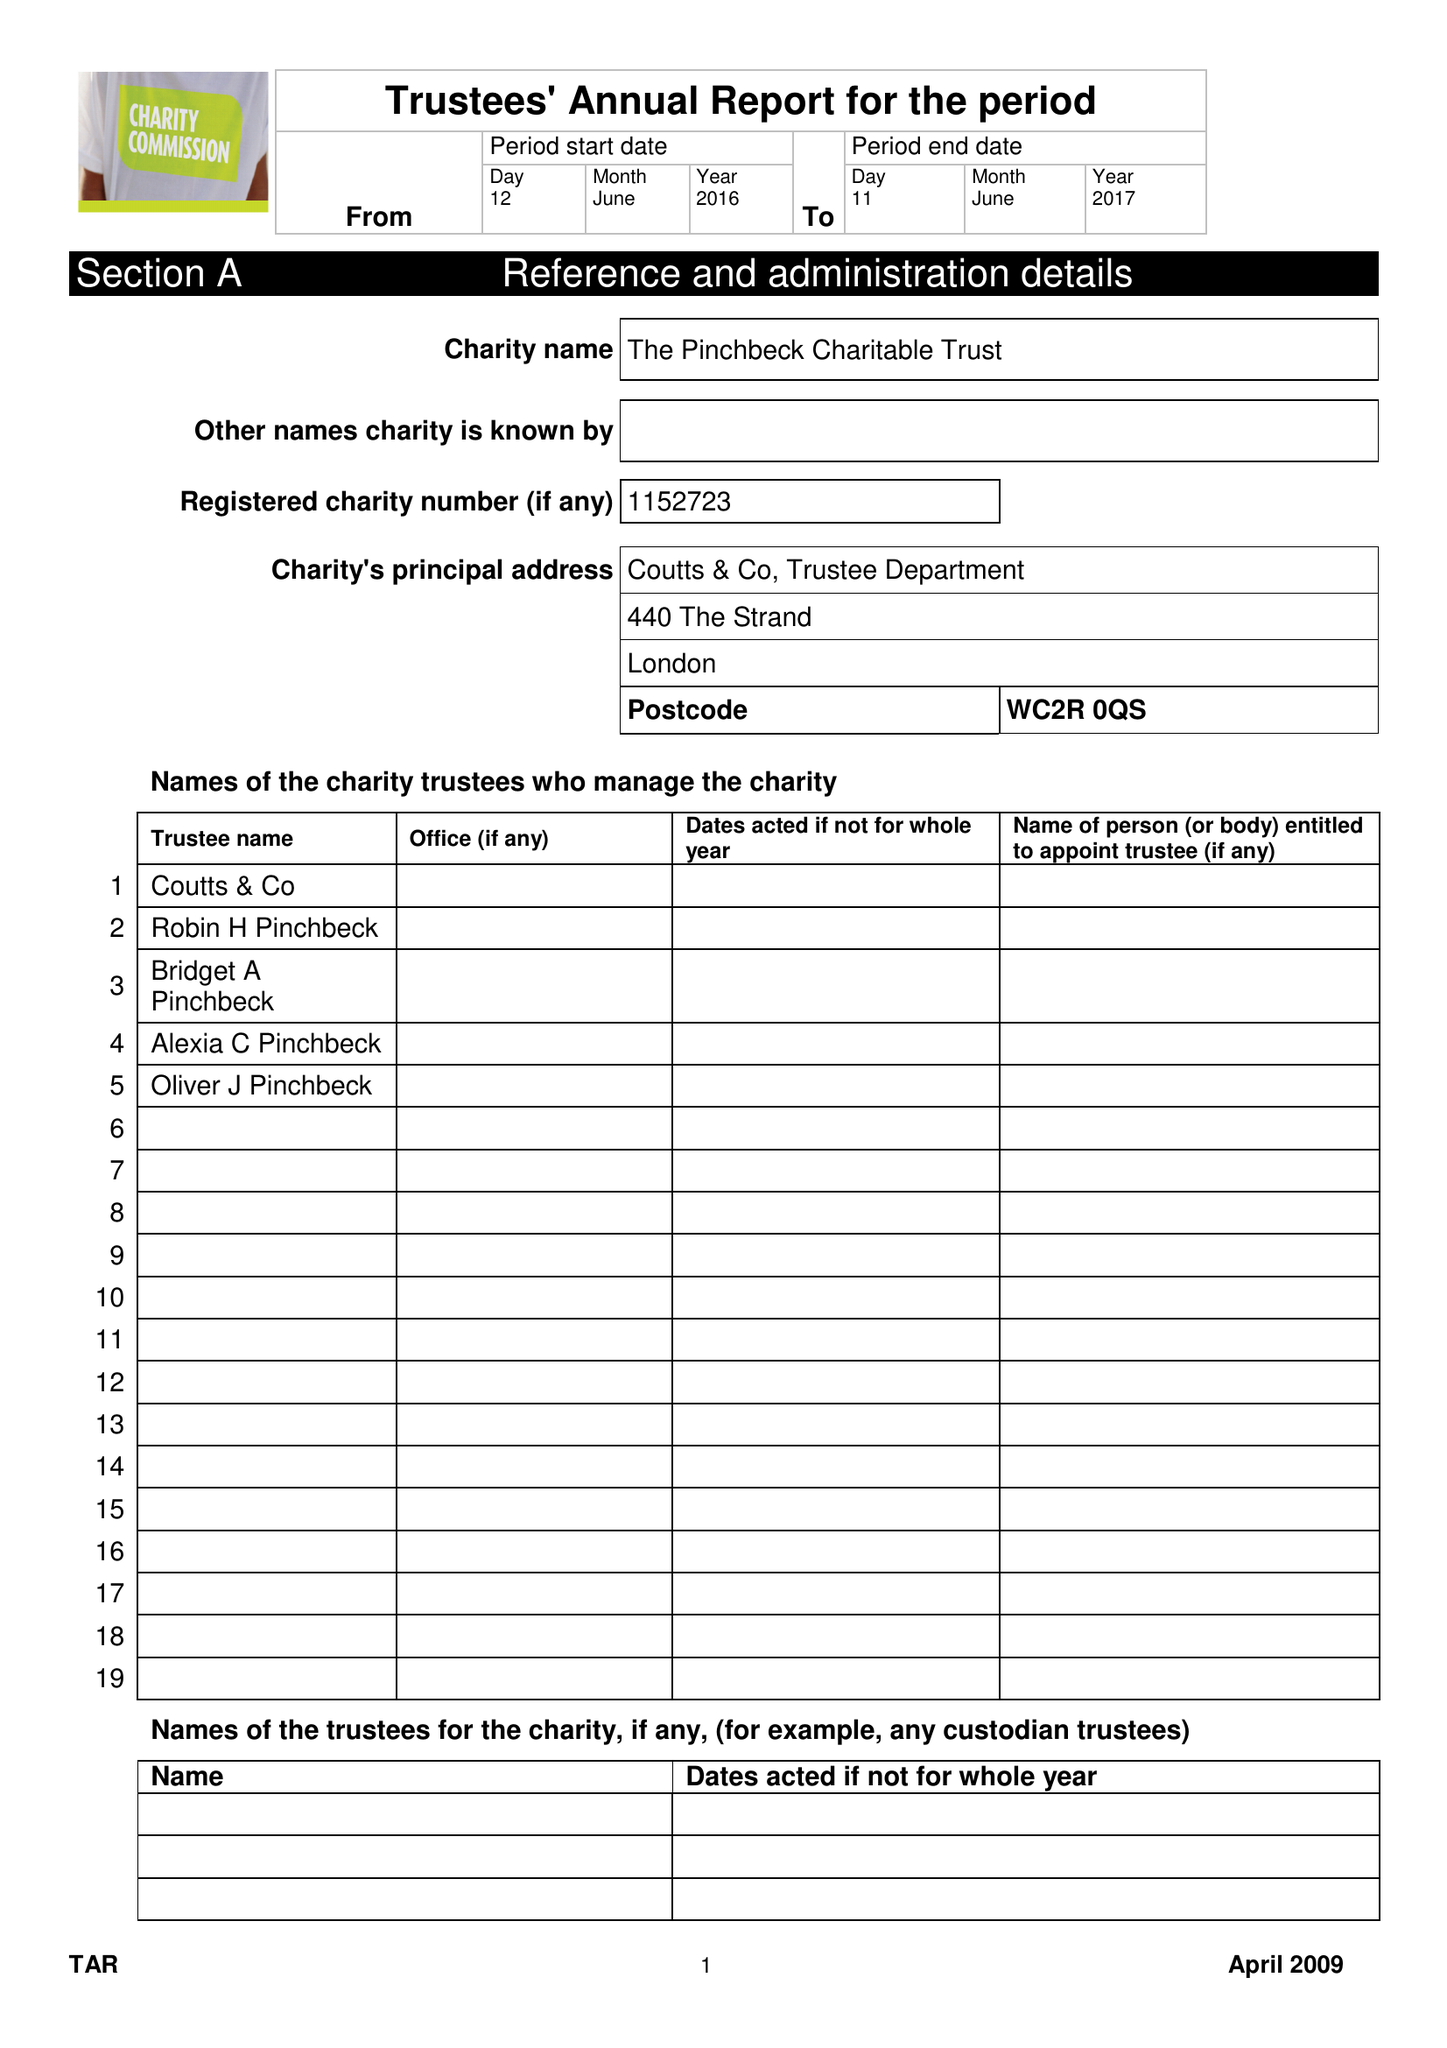What is the value for the address__post_town?
Answer the question using a single word or phrase. LONDON 